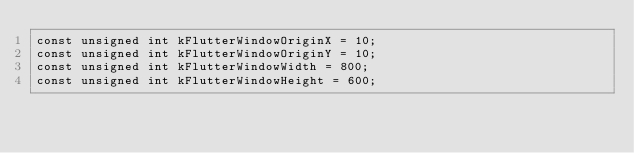<code> <loc_0><loc_0><loc_500><loc_500><_C++_>const unsigned int kFlutterWindowOriginX = 10;
const unsigned int kFlutterWindowOriginY = 10;
const unsigned int kFlutterWindowWidth = 800;
const unsigned int kFlutterWindowHeight = 600;
</code> 